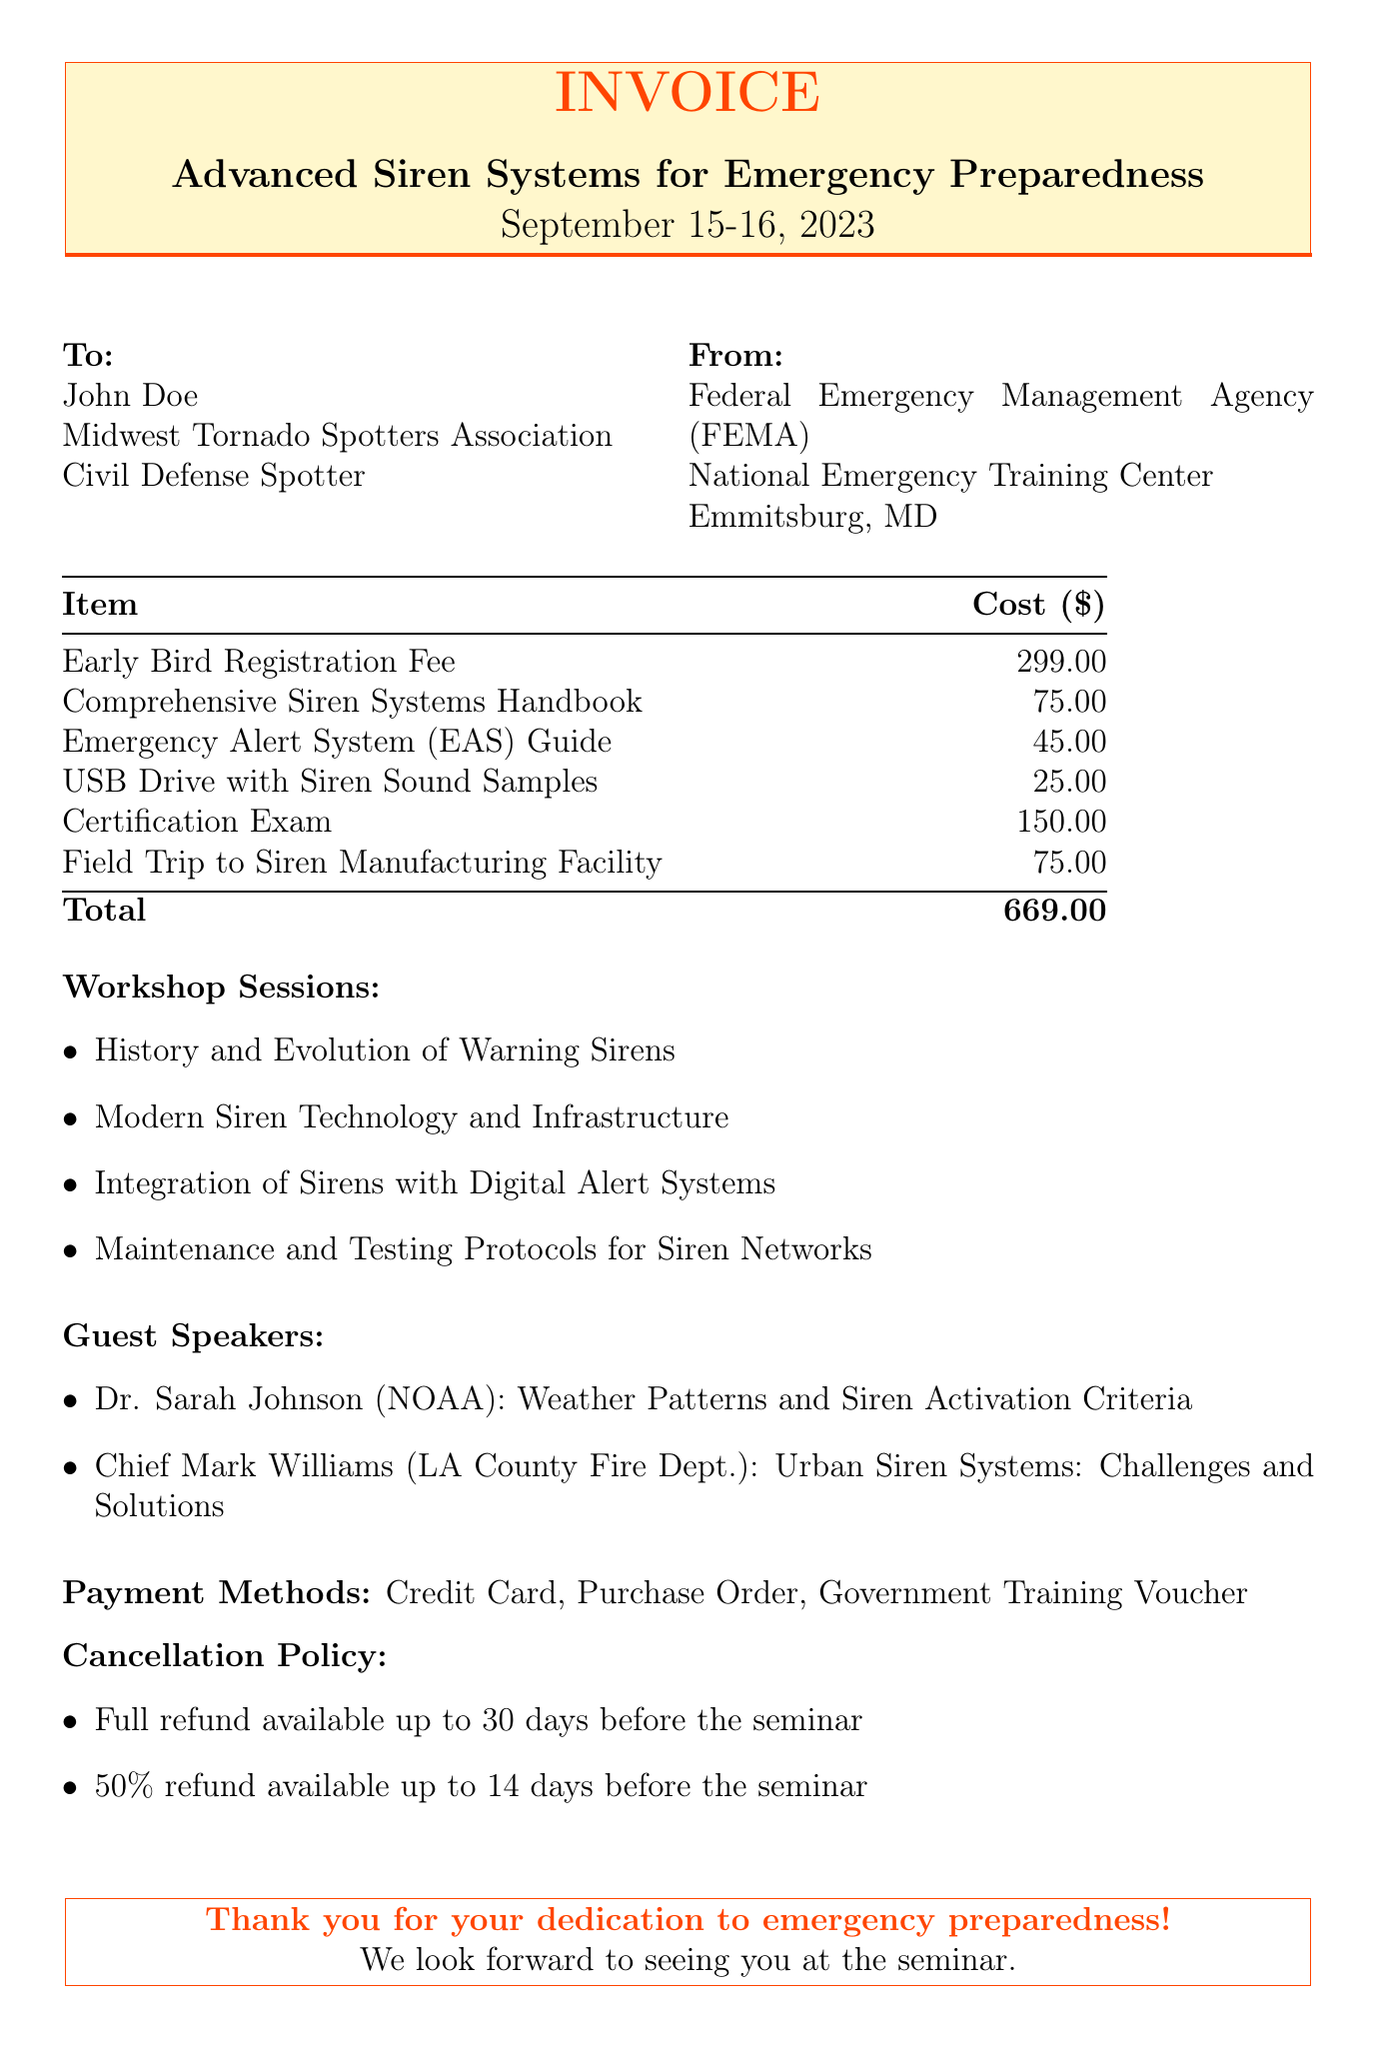What is the title of the seminar? The title of the seminar is provided in the document under seminar details.
Answer: Advanced Siren Systems for Emergency Preparedness When is the seminar scheduled? The date of the seminar is specified clearly under the seminar details.
Answer: September 15-16, 2023 Who is the organizer of the seminar? The organizer is mentioned in the seminar details section of the document.
Answer: Federal Emergency Management Agency (FEMA) What is the cost of the certification exam? The cost is listed under additional costs in the document.
Answer: 150.00 What is the total cost including registration fees and materials? The total cost is the sum of all fees and materials listed in the document.
Answer: 669.00 Which guest speaker is affiliated with NOAA? The guest speakers section lists their affiliations and topics they will discuss.
Answer: Dr. Sarah Johnson What is the cancellation policy for a full refund? The cancellation policy details the conditions for refunds specified in the document.
Answer: 30 days before seminar What payment methods are accepted? The payment methods are listed in a dedicated section of the document.
Answer: Credit Card, Purchase Order, Government Training Voucher What item costs $25.00? The materials provided section includes details of individual material costs.
Answer: USB Drive with Siren Sound Samples 